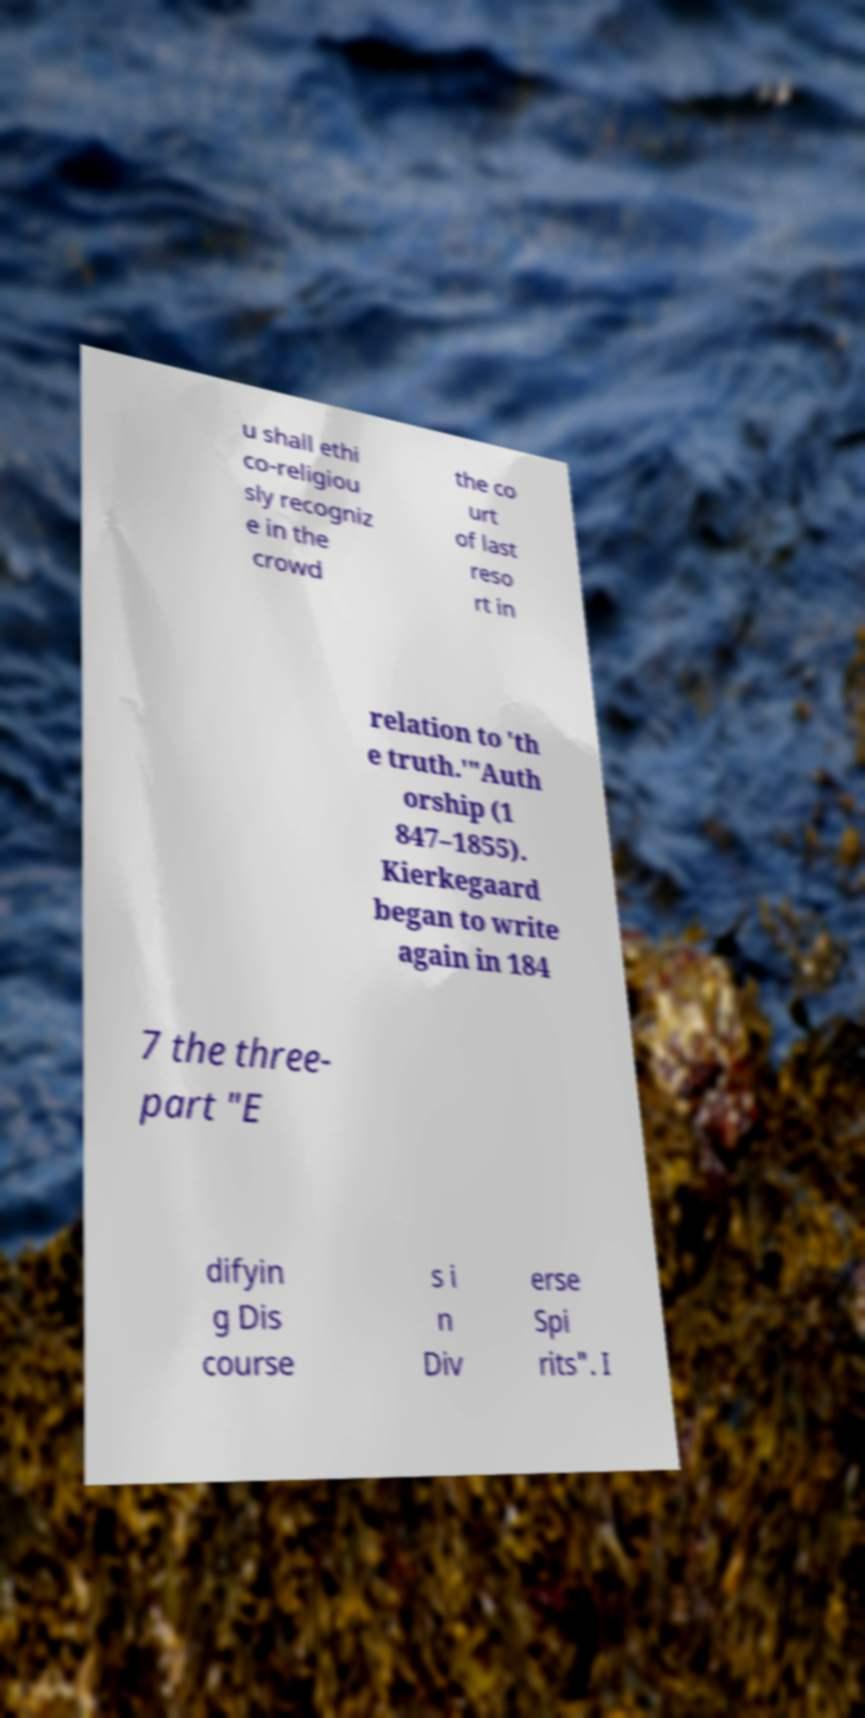What messages or text are displayed in this image? I need them in a readable, typed format. u shall ethi co-religiou sly recogniz e in the crowd the co urt of last reso rt in relation to 'th e truth.'"Auth orship (1 847–1855). Kierkegaard began to write again in 184 7 the three- part "E difyin g Dis course s i n Div erse Spi rits". I 